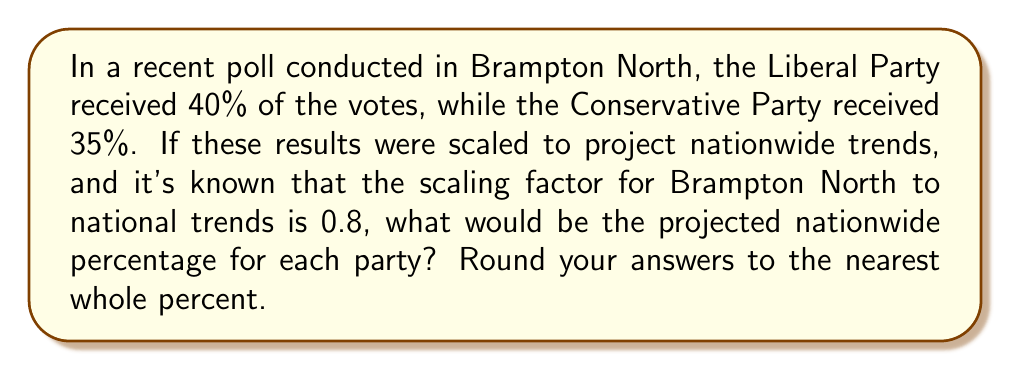Give your solution to this math problem. To solve this problem, we need to apply the scaling factor to the local poll results:

1. For the Liberal Party:
   $$ \text{Nationwide projection} = \text{Local percentage} \times \text{Scaling factor} $$
   $$ = 40\% \times 0.8 = 32\% $$

2. For the Conservative Party:
   $$ \text{Nationwide projection} = \text{Local percentage} \times \text{Scaling factor} $$
   $$ = 35\% \times 0.8 = 28\% $$

3. Rounding to the nearest whole percent:
   Liberal Party: 32% (no rounding needed)
   Conservative Party: 28% (no rounding needed)

The scaling factor of 0.8 indicates that the local poll results in Brampton North tend to overestimate the nationwide trends. This could be due to various factors such as demographic differences or regional political preferences.
Answer: Liberal Party: 32%, Conservative Party: 28% 